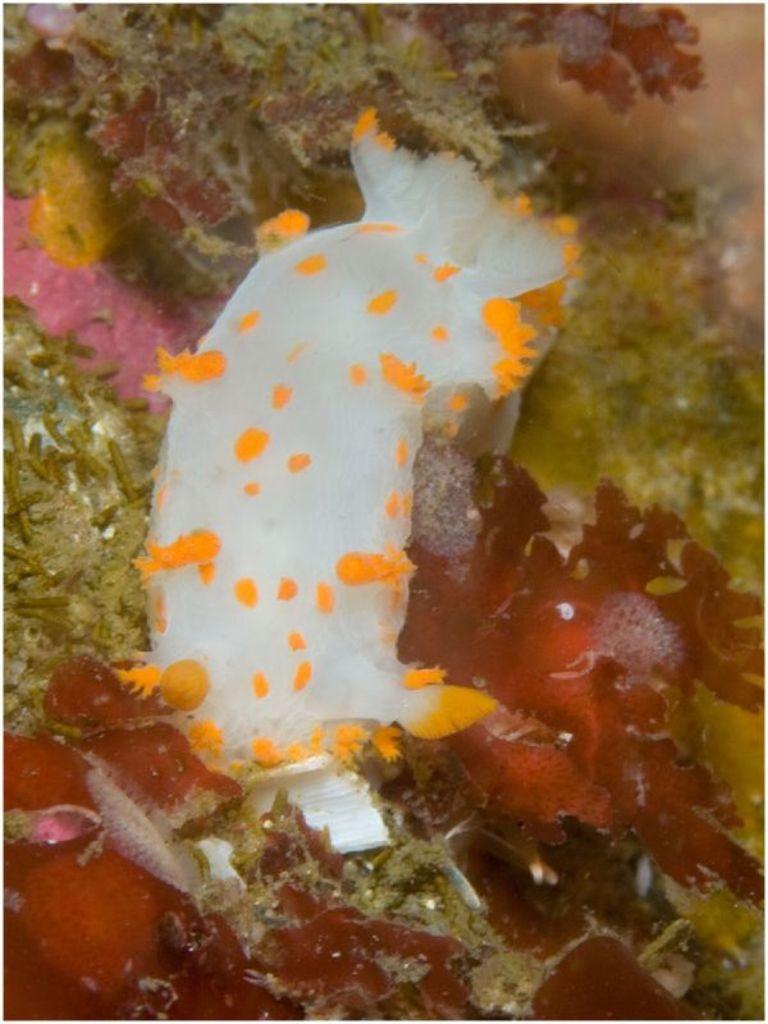Please provide a concise description of this image. In the image I can see fishes in the water. I can also see plants and some other objects. 